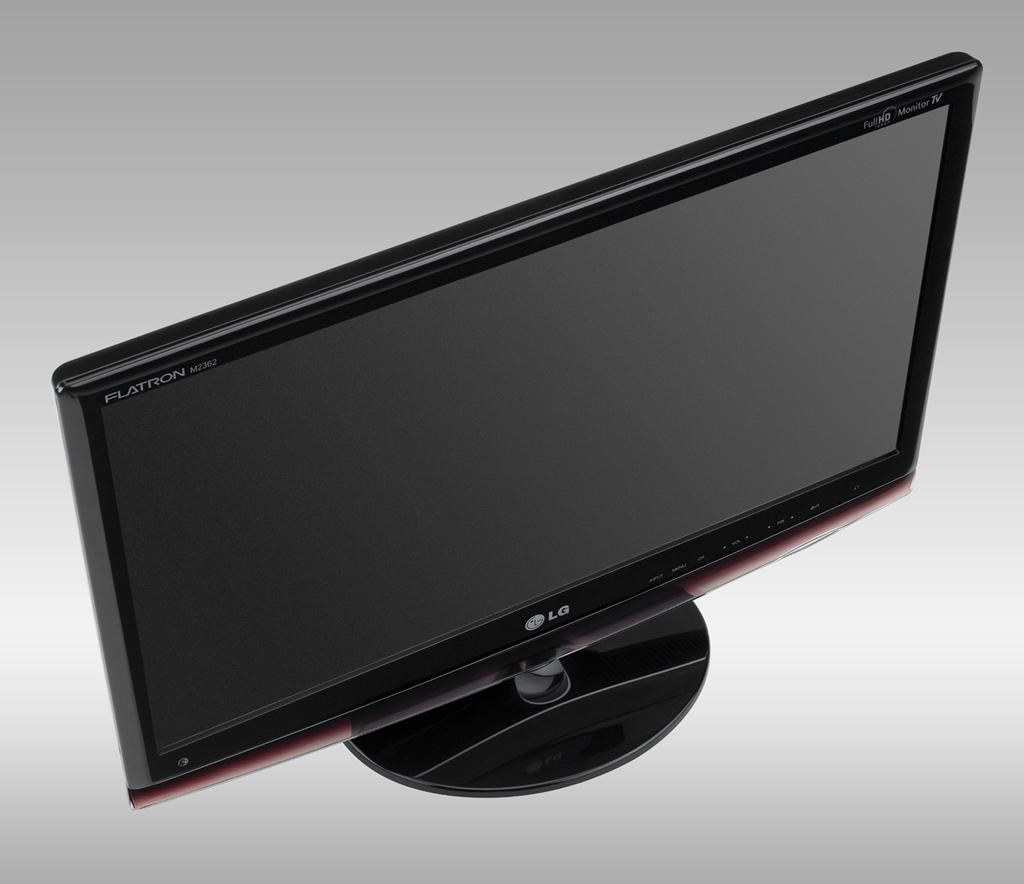Provide a one-sentence caption for the provided image. An LG black flatscreen tv is sitting on a surface. 